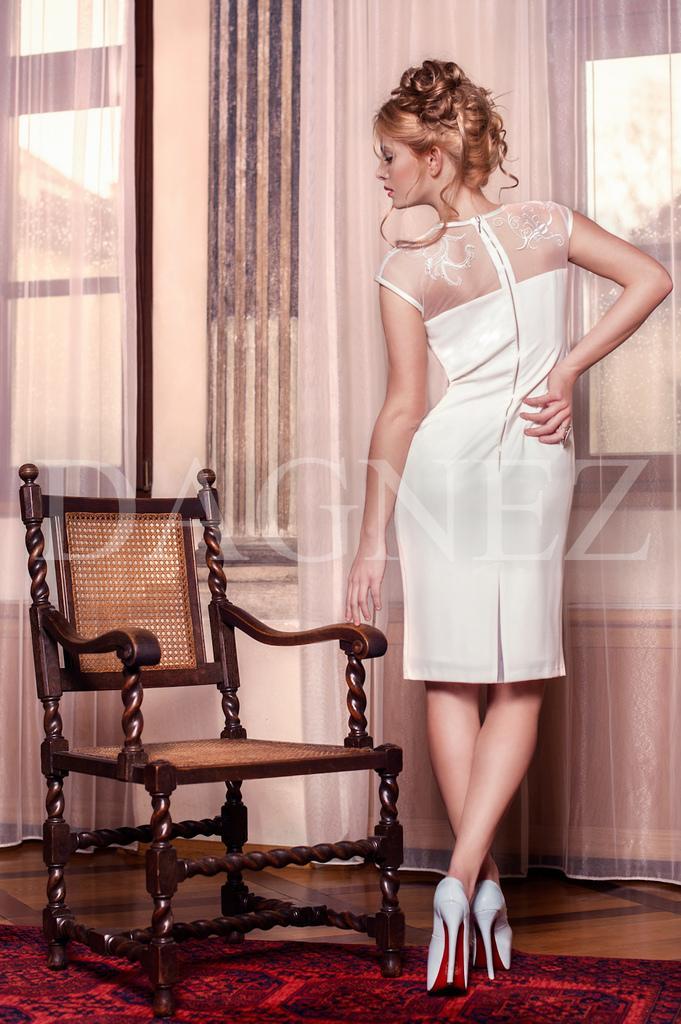Can you describe this image briefly? In this image I can see a woman in white dress. Here I can see a chair. 